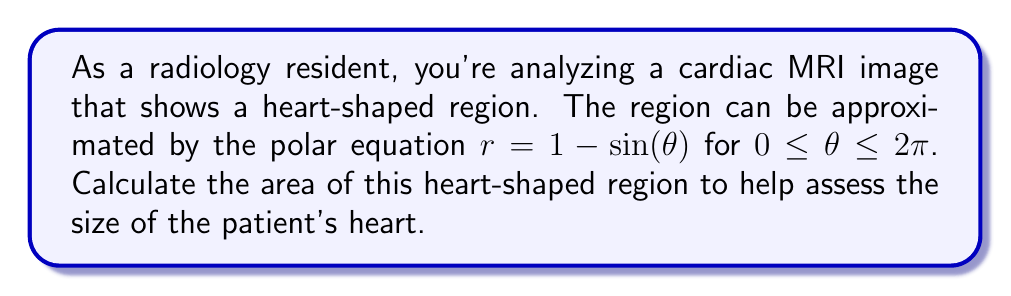What is the answer to this math problem? To calculate the area of the heart-shaped region, we'll use the formula for area in polar coordinates:

$$A = \frac{1}{2} \int_{0}^{2\pi} r^2 d\theta$$

Where $r = 1 - \sin(\theta)$

Step 1: Square the radius function
$r^2 = (1 - \sin(\theta))^2 = 1 - 2\sin(\theta) + \sin^2(\theta)$

Step 2: Substitute $r^2$ into the area formula
$$A = \frac{1}{2} \int_{0}^{2\pi} (1 - 2\sin(\theta) + \sin^2(\theta)) d\theta$$

Step 3: Integrate each term
$$A = \frac{1}{2} \left[ \theta - 2(-\cos(\theta)) + \frac{\theta}{2} - \frac{\sin(2\theta)}{4} \right]_{0}^{2\pi}$$

Step 4: Evaluate the integral
$$A = \frac{1}{2} \left[ 2\pi - 2(0) + \pi - 0 \right] - \frac{1}{2} \left[ 0 - 2(1) + 0 - 0 \right]$$

Step 5: Simplify
$$A = \frac{1}{2} (3\pi) + 1 = \frac{3\pi}{2} + 1$$

[asy]
import graph;
size(200);
real r(real t) {return 1-sin(t);}
path heart = polargraph(r,0,2pi);
draw(heart,red);
xaxis(arrow=Arrow);
yaxis(arrow=Arrow);
label("$x$",(1.2,0),E);
label("$y$",(0,1.2),N);
[/asy]
Answer: The area of the heart-shaped region is $\frac{3\pi}{2} + 1$ square units. 